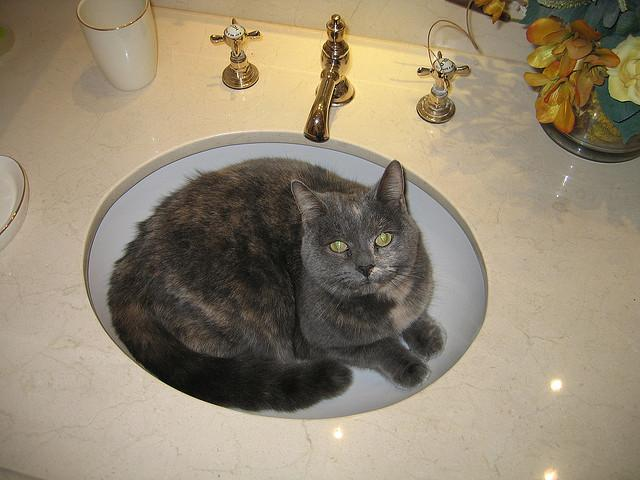Why should this cat be scared? water 